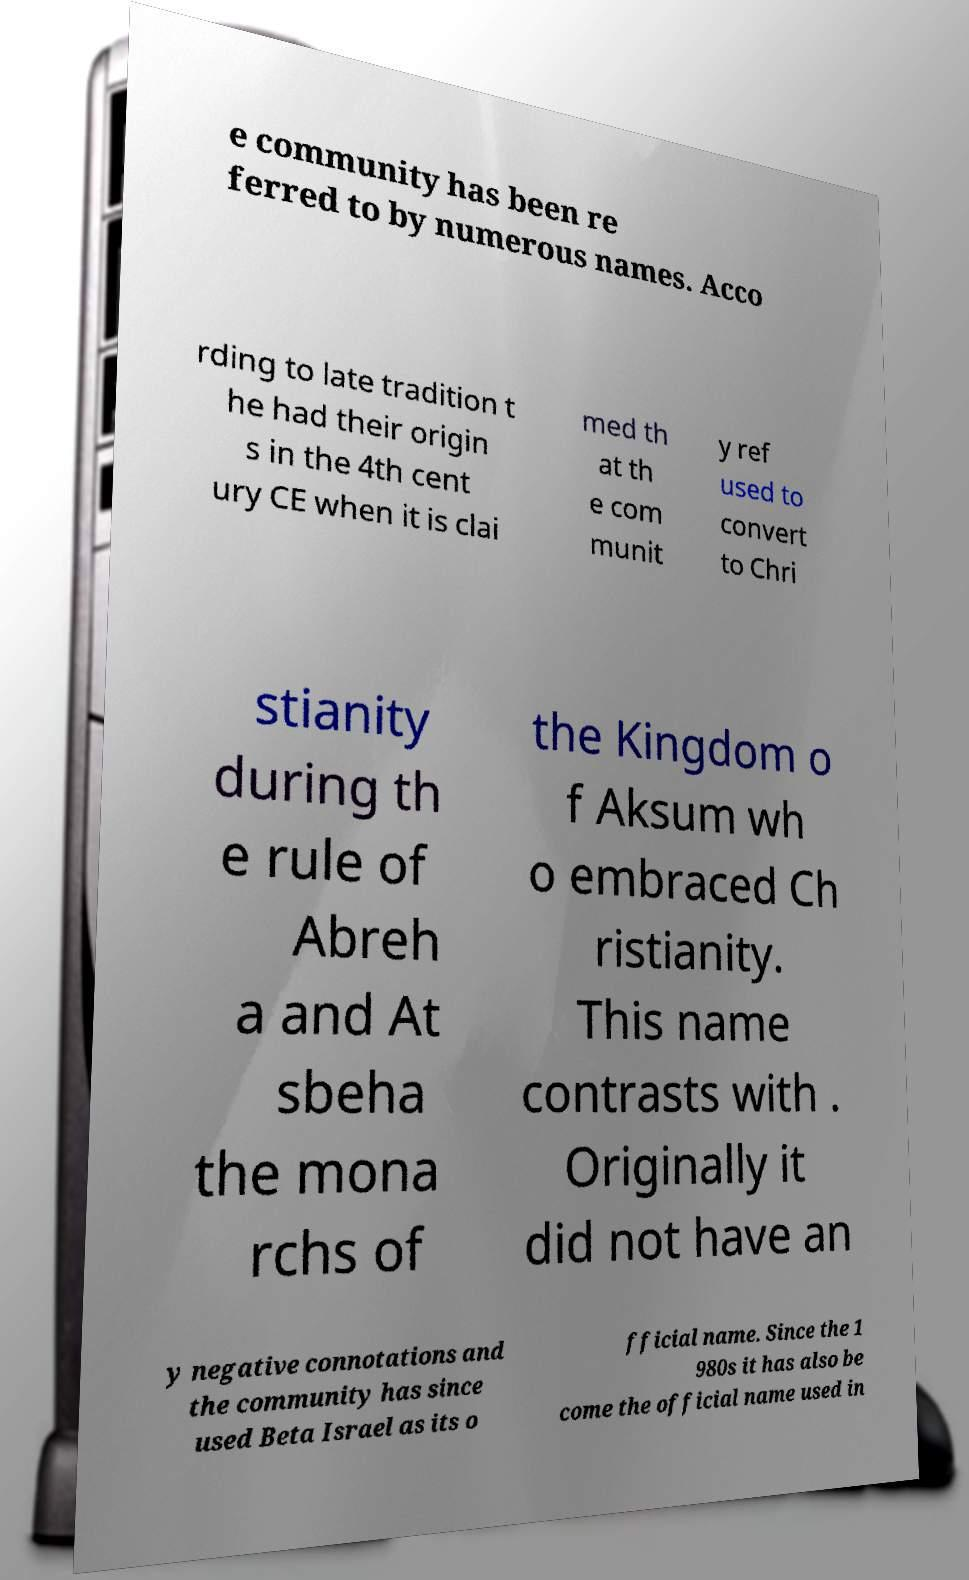For documentation purposes, I need the text within this image transcribed. Could you provide that? e community has been re ferred to by numerous names. Acco rding to late tradition t he had their origin s in the 4th cent ury CE when it is clai med th at th e com munit y ref used to convert to Chri stianity during th e rule of Abreh a and At sbeha the mona rchs of the Kingdom o f Aksum wh o embraced Ch ristianity. This name contrasts with . Originally it did not have an y negative connotations and the community has since used Beta Israel as its o fficial name. Since the 1 980s it has also be come the official name used in 